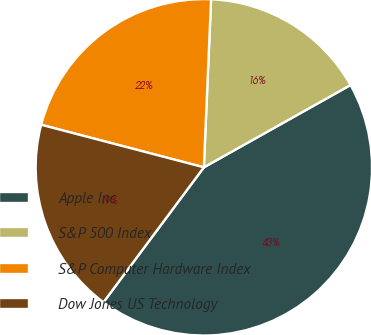Convert chart to OTSL. <chart><loc_0><loc_0><loc_500><loc_500><pie_chart><fcel>Apple Inc<fcel>S&P 500 Index<fcel>S&P Computer Hardware Index<fcel>Dow Jones US Technology<nl><fcel>43.32%<fcel>16.18%<fcel>21.61%<fcel>18.89%<nl></chart> 